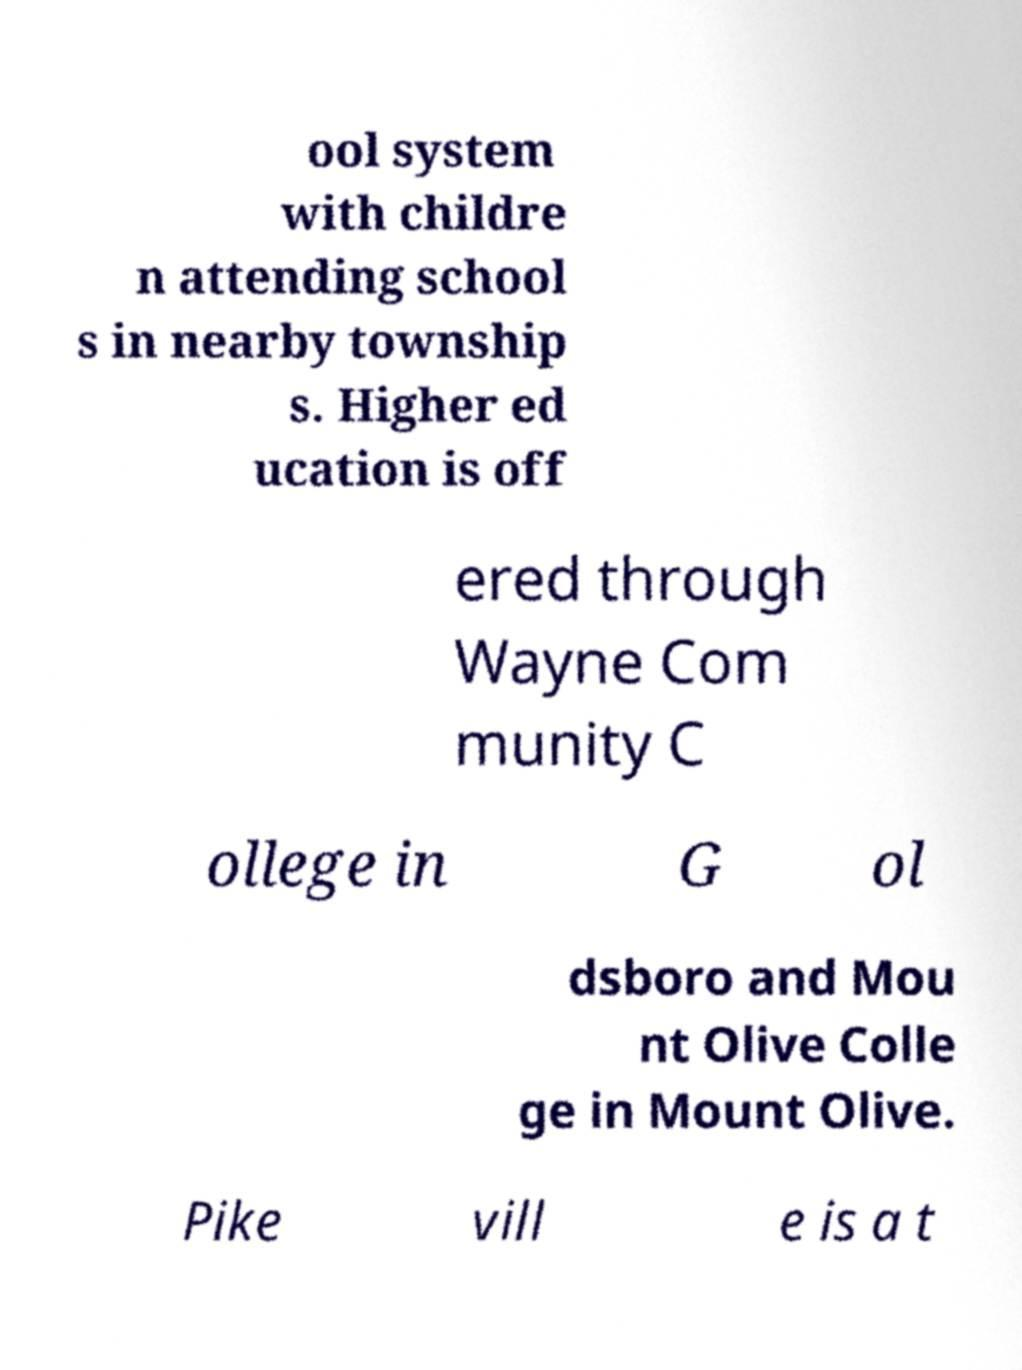Could you extract and type out the text from this image? ool system with childre n attending school s in nearby township s. Higher ed ucation is off ered through Wayne Com munity C ollege in G ol dsboro and Mou nt Olive Colle ge in Mount Olive. Pike vill e is a t 